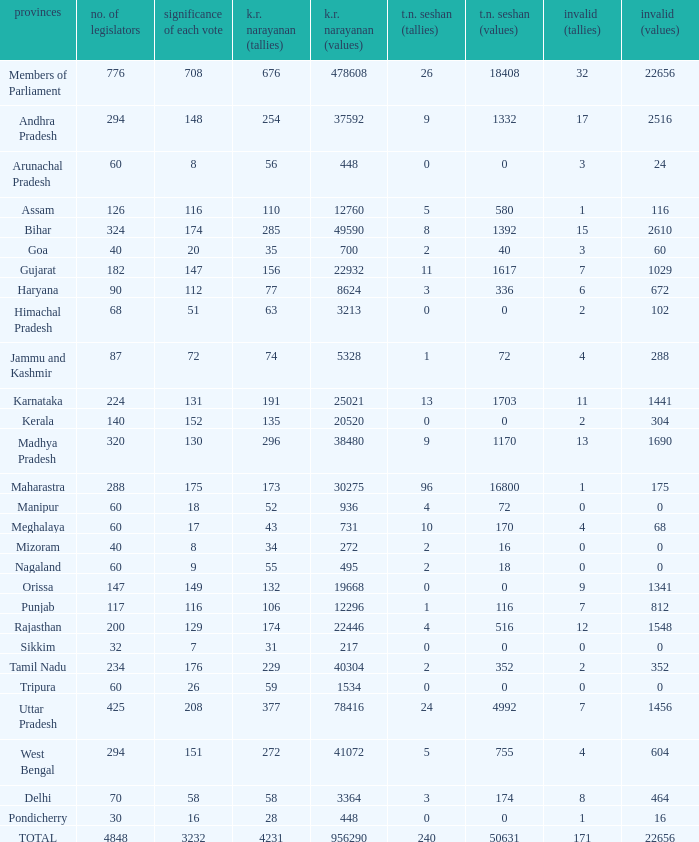Name the k. r. narayanan values for pondicherry 448.0. 